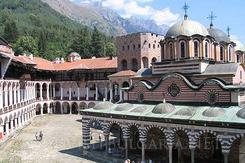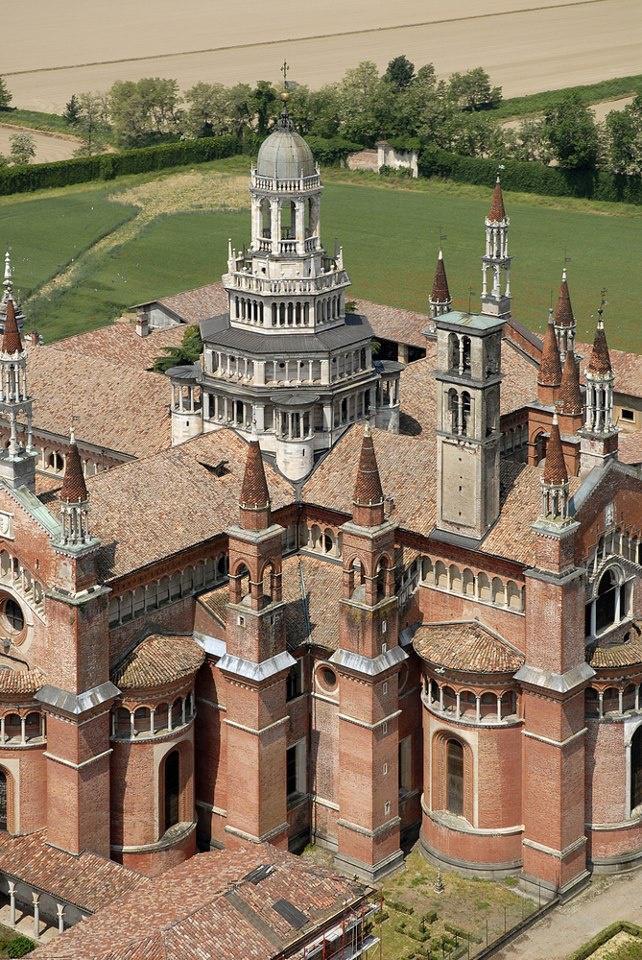The first image is the image on the left, the second image is the image on the right. Evaluate the accuracy of this statement regarding the images: "In at least one image there is a squared white walled building with at least three floors.". Is it true? Answer yes or no. No. 